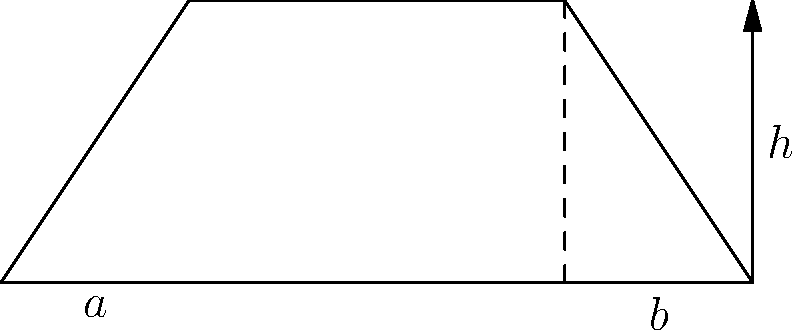In a legal property dispute, you're presented with a trapezoid-shaped land parcel. The parallel sides measure 4 units and 12 units, respectively, and the height of the trapezoid is 6 units. Calculate the area of this land parcel. How might this calculation be relevant in resolving property boundary issues? To calculate the area of a trapezoid, we use the formula:

$$A = \frac{1}{2}(a+b)h$$

Where:
$A$ = Area of the trapezoid
$a$ = Length of one parallel side
$b$ = Length of the other parallel side
$h$ = Height of the trapezoid

Given:
$a = 4$ units
$b = 12$ units
$h = 6$ units

Let's substitute these values into the formula:

$$A = \frac{1}{2}(4+12) \times 6$$

$$A = \frac{1}{2}(16) \times 6$$

$$A = 8 \times 6$$

$$A = 48$$

Therefore, the area of the trapezoid-shaped land parcel is 48 square units.

This calculation is relevant in property boundary disputes as it provides an accurate measure of the land area in question. It can be used to determine fair property values, settle disputes over land usage rights, or establish proper zoning regulations. In legal contexts, precise measurements are crucial for making equitable judgments and ensuring that all parties receive their rightful share of property.
Answer: 48 square units 